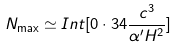Convert formula to latex. <formula><loc_0><loc_0><loc_500><loc_500>N _ { \max } \simeq I n t [ 0 \cdot 3 4 \frac { c ^ { 3 } } { \alpha ^ { \prime } H ^ { 2 } } ]</formula> 